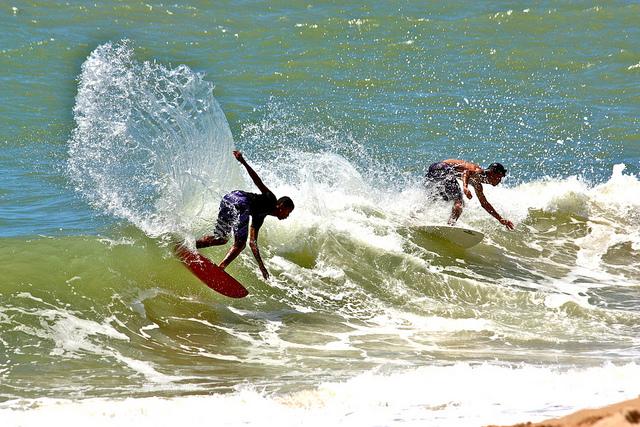Are they racing?
Answer briefly. No. How many surfers?
Give a very brief answer. 2. What are these men doing?
Keep it brief. Surfing. 